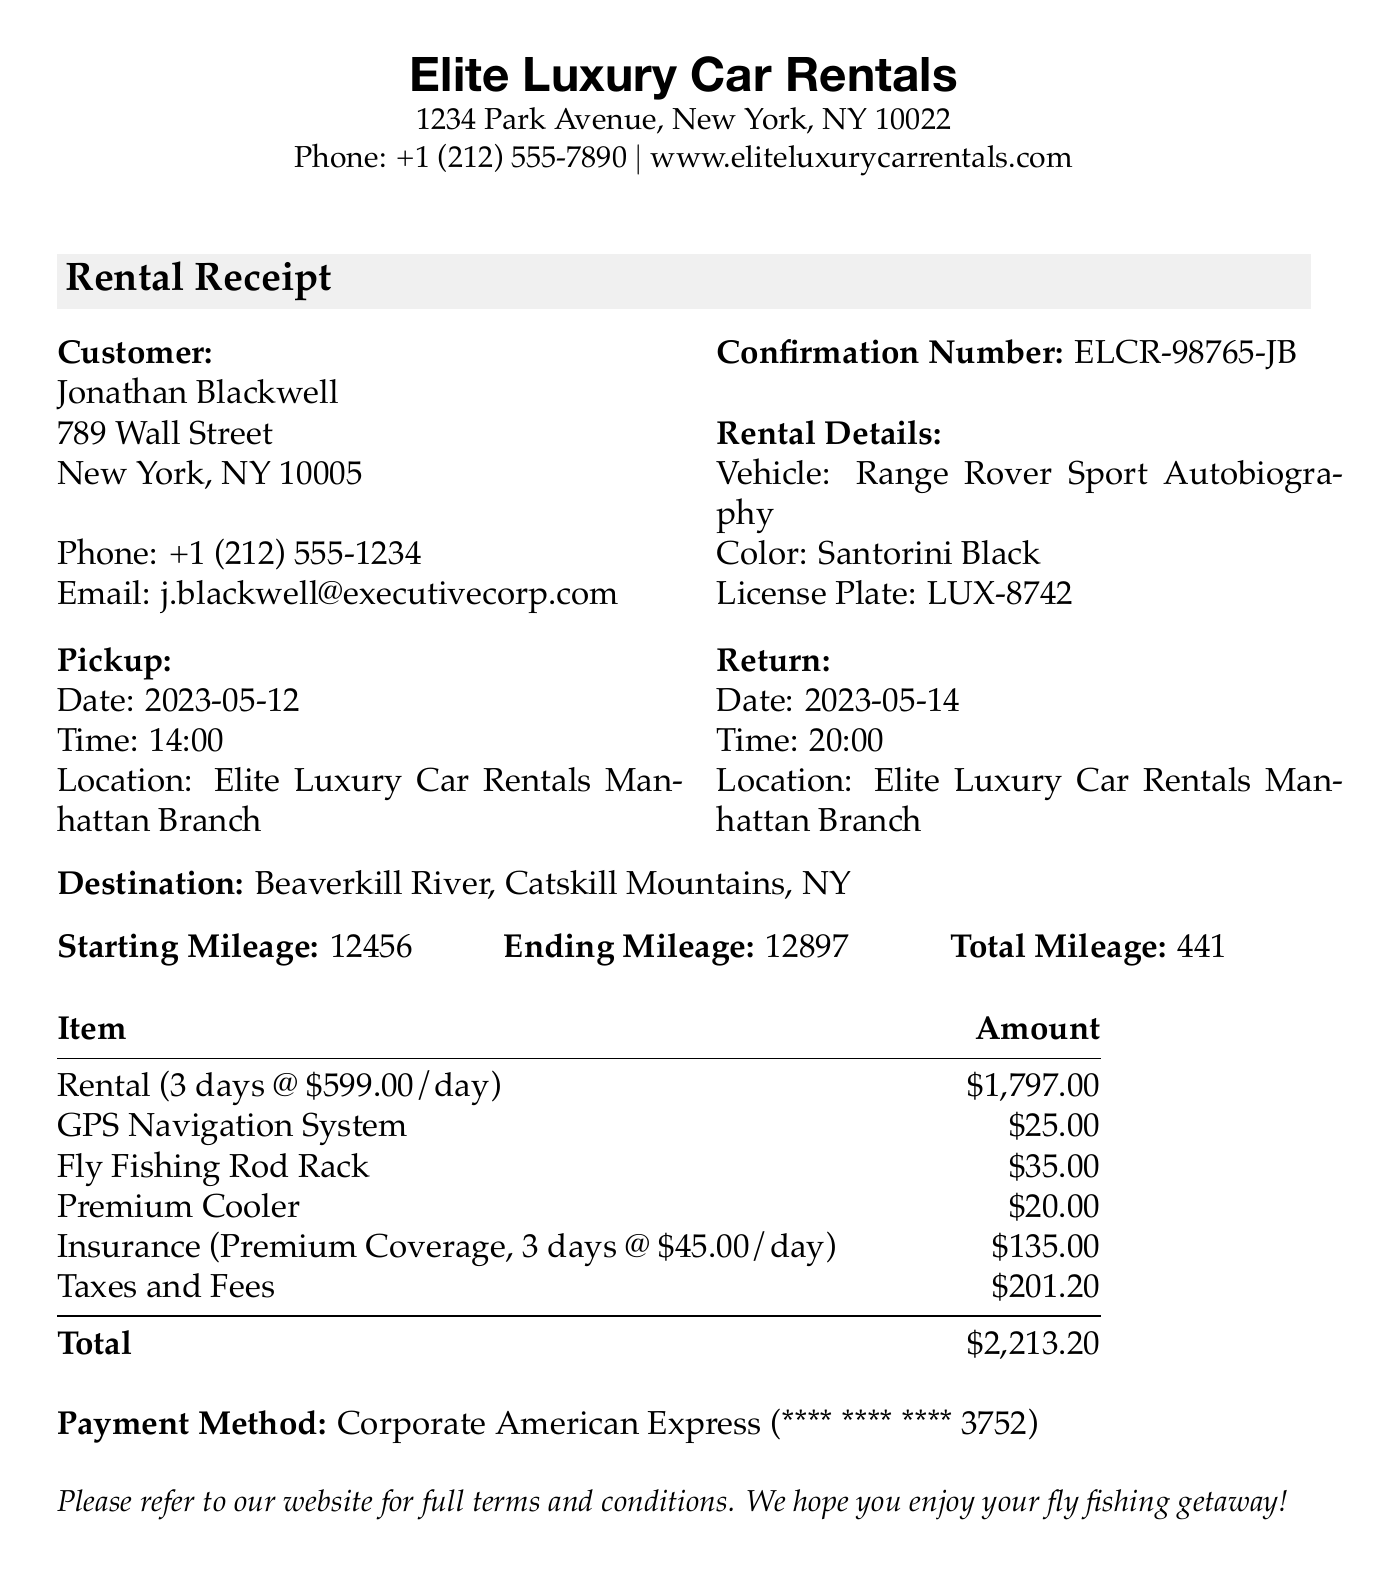What is the name of the rental company? The name of the rental company is stated at the top of the receipt.
Answer: Elite Luxury Car Rentals What vehicle was rented? The vehicle rented is specified in the rental details section of the document.
Answer: Range Rover Sport Autobiography What is the total amount charged? The total amount charged is found at the bottom of the pricing section.
Answer: $2,213.20 What is the pickup date? The pickup date is listed under the rental details.
Answer: 2023-05-12 How many days was the rental? The number of days rented can be calculated from the pickup and return dates provided.
Answer: 3 What additional service cost the most? The additional services list shows the prices for each item, which allows for comparison.
Answer: Fly Fishing Rod Rack What is the daily rate for rental? The daily rate is mentioned in the pricing section of the document.
Answer: $599.00 What type of insurance was selected? The type of insurance is specified in the insurance section of the receipt.
Answer: Premium Coverage What was the starting mileage? The starting mileage is indicated in the mileage section of the document.
Answer: 12456 